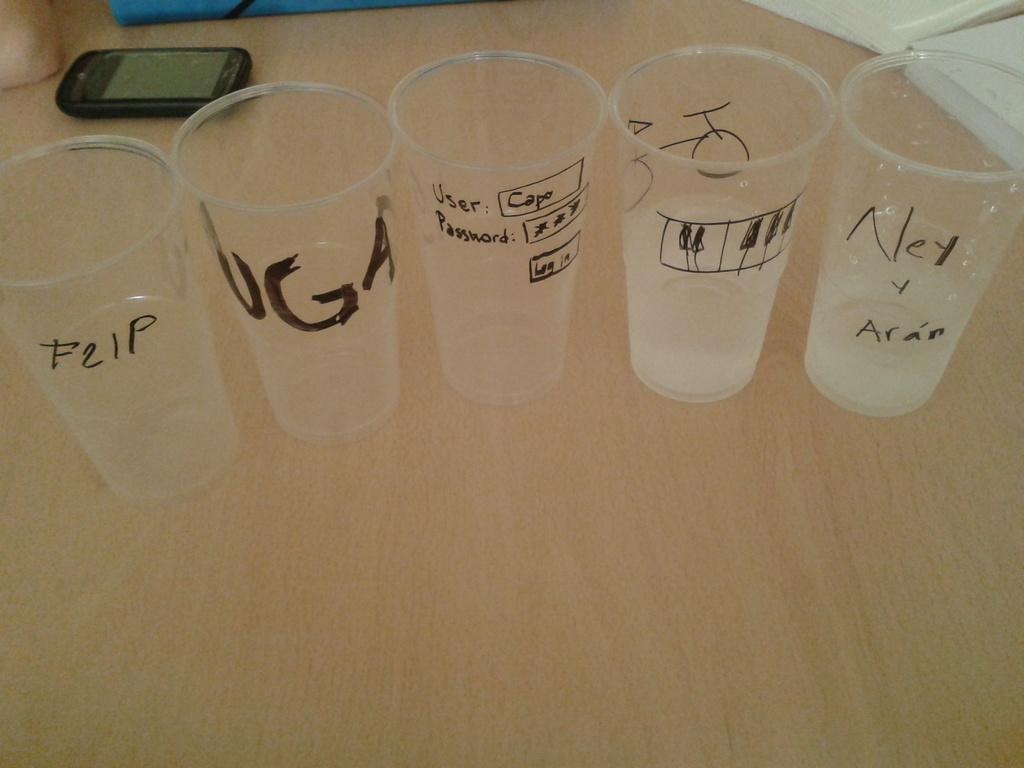<image>
Render a clear and concise summary of the photo. Five clear plastic cups sits on a table with UGA written on one 